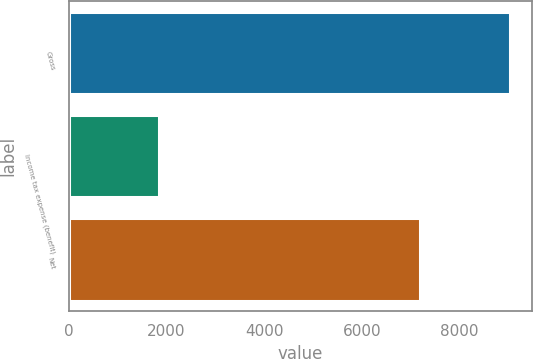Convert chart. <chart><loc_0><loc_0><loc_500><loc_500><bar_chart><fcel>Gross<fcel>Income tax expense (benefit)<fcel>Net<nl><fcel>9031<fcel>1841<fcel>7190<nl></chart> 